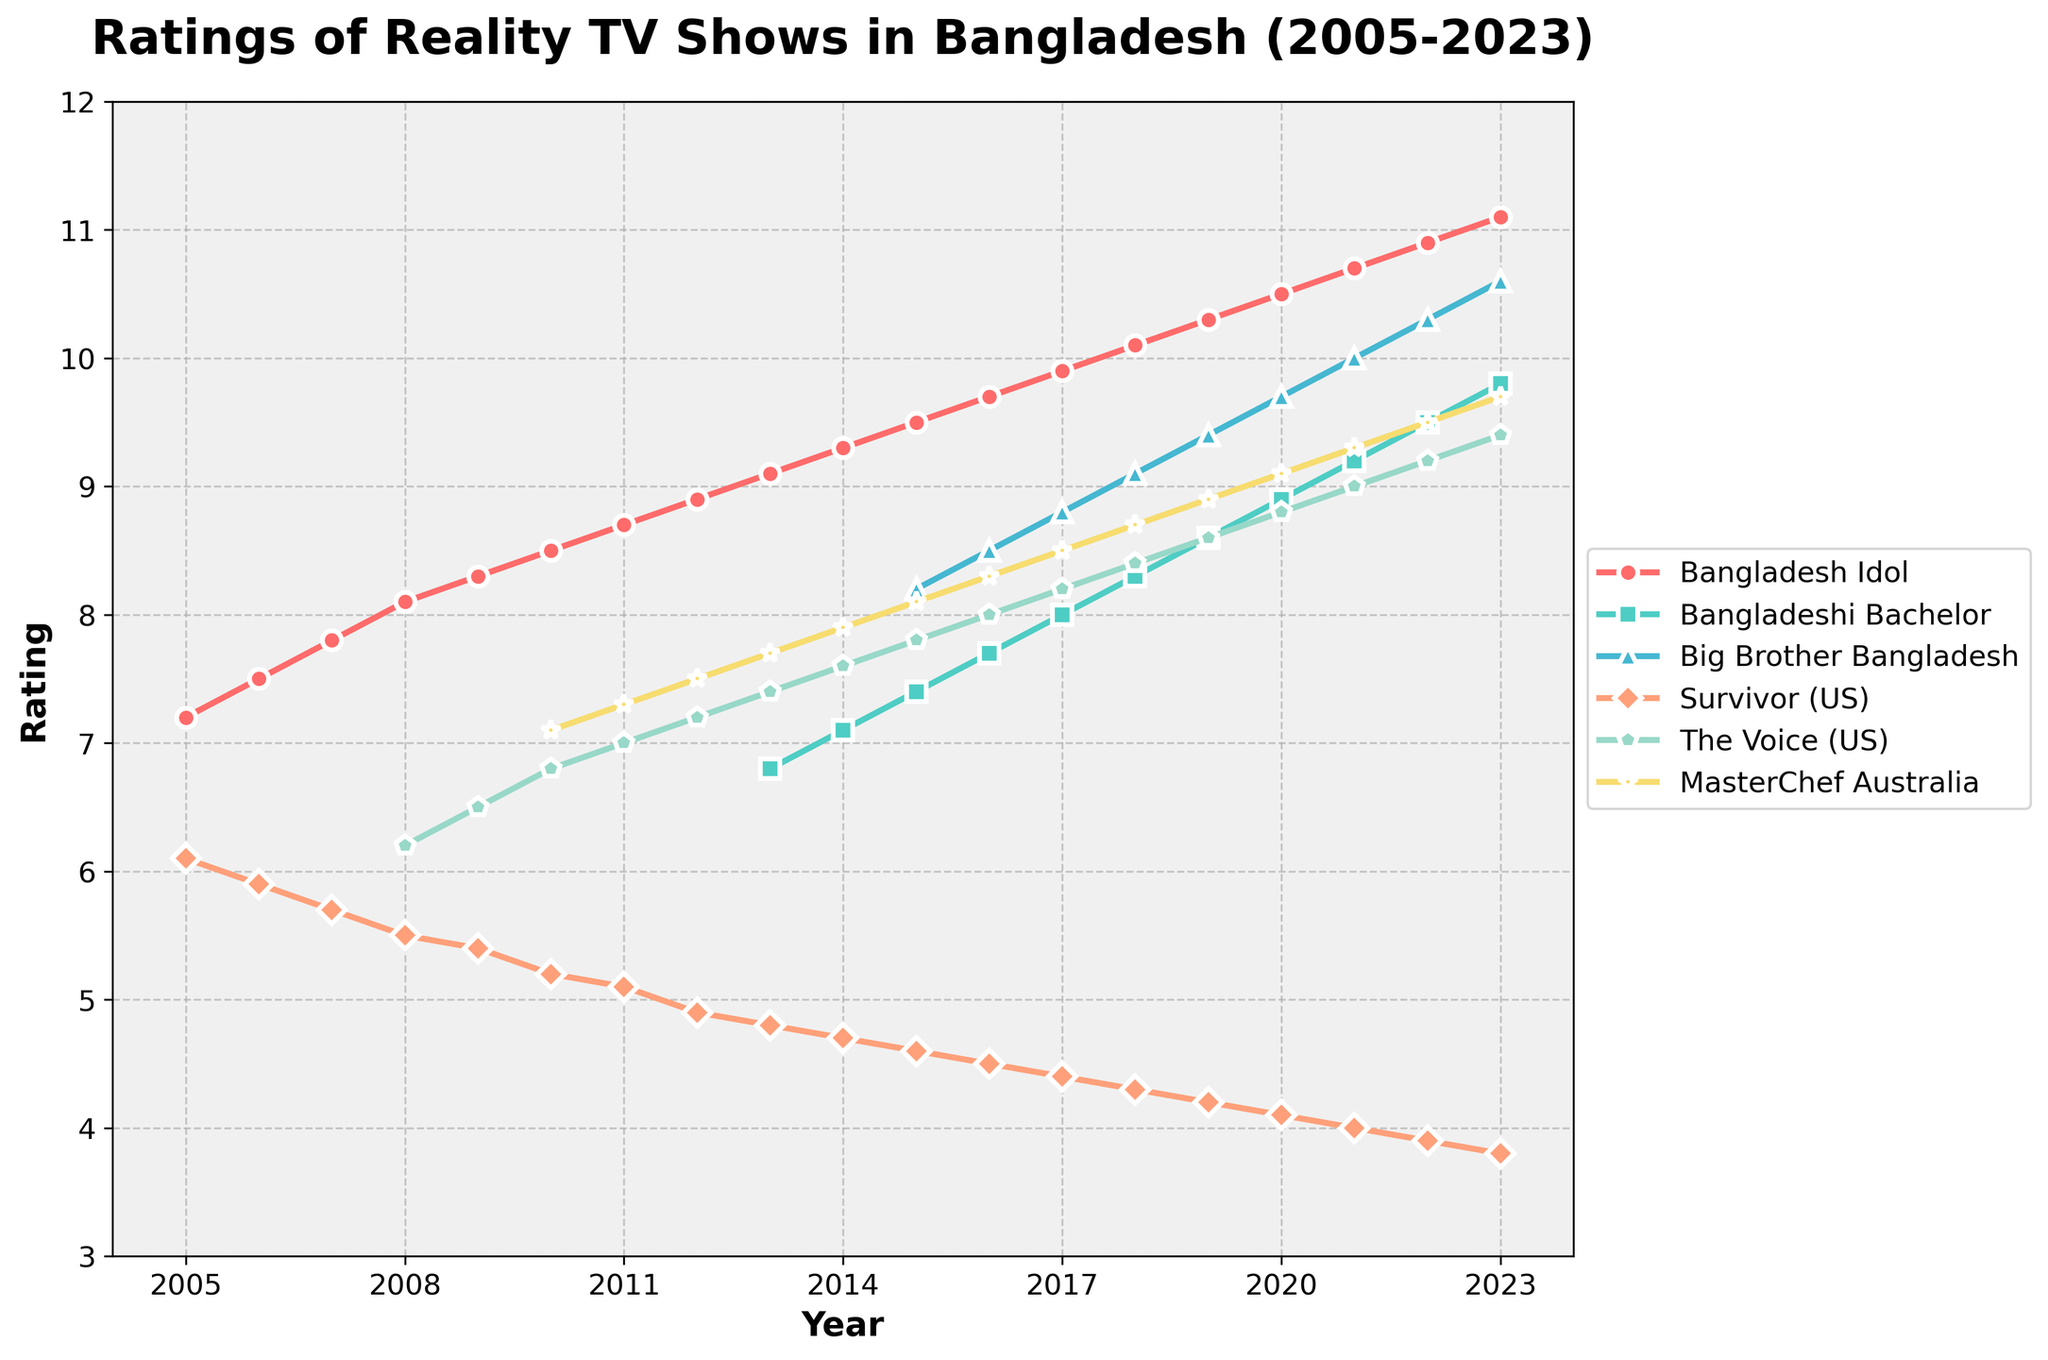What years did 'Bangladesh Idol' experience its highest ratings? The line for 'Bangladesh Idol' shows a steady increase over the years, peaking in the latest year. The highest rating is at the end of the timeline.
Answer: 2023 How do the ratings of 'Survivor (US)' compare to 'Bangladesh Idol' in 2011? Look at the 2011 data points for 'Survivor (US)' and 'Bangladesh Idol'. 'Bangladesh Idol' has a rating of 8.7, while 'Survivor (US)' has a rating of 5.1.
Answer: 'Bangladesh Idol' > 'Survivor (US)' During which year did 'The Voice (US)' surpass a rating of 8.0? Follow the trajectory of 'The Voice (US)' and identify the point where it crosses the 8.0 rating line. It crosses in 2016.
Answer: 2016 What is the average rating of 'Big Brother Bangladesh' from 2015 to 2023? Sum the ratings of 'Big Brother Bangladesh' from 2015 to 2023 and then divide by the number of years: (8.2 + 8.5 + 8.8 + 9.1 + 9.4 + 9.7 + 10.0 + 10.3 + 10.6)/9 = 9.4
Answer: 9.4 Which show has the highest rating in 2023? Check the ratings of all shows in 2023 and find the highest value. 'Bangladesh Idol' has the highest rating of 11.1.
Answer: 'Bangladesh Idol' Compare the ratings of 'Bangladeshi Bachelor' in 2020 and 'MasterChef Australia' in the same year. Which one is higher? Compare 'Bangladeshi Bachelor' rating of 8.9 with 'MasterChef Australia' rating of 9.1 for the year 2020. 'MasterChef Australia' is higher.
Answer: 'MasterChef Australia' In which year did 'Survivor (US)' experience the biggest drop in ratings? Observe the trend of 'Survivor (US)' ratings and find the year with the steepest decline. The largest drop occurred between 2011 (5.1) and 2012 (4.9).
Answer: 2012 